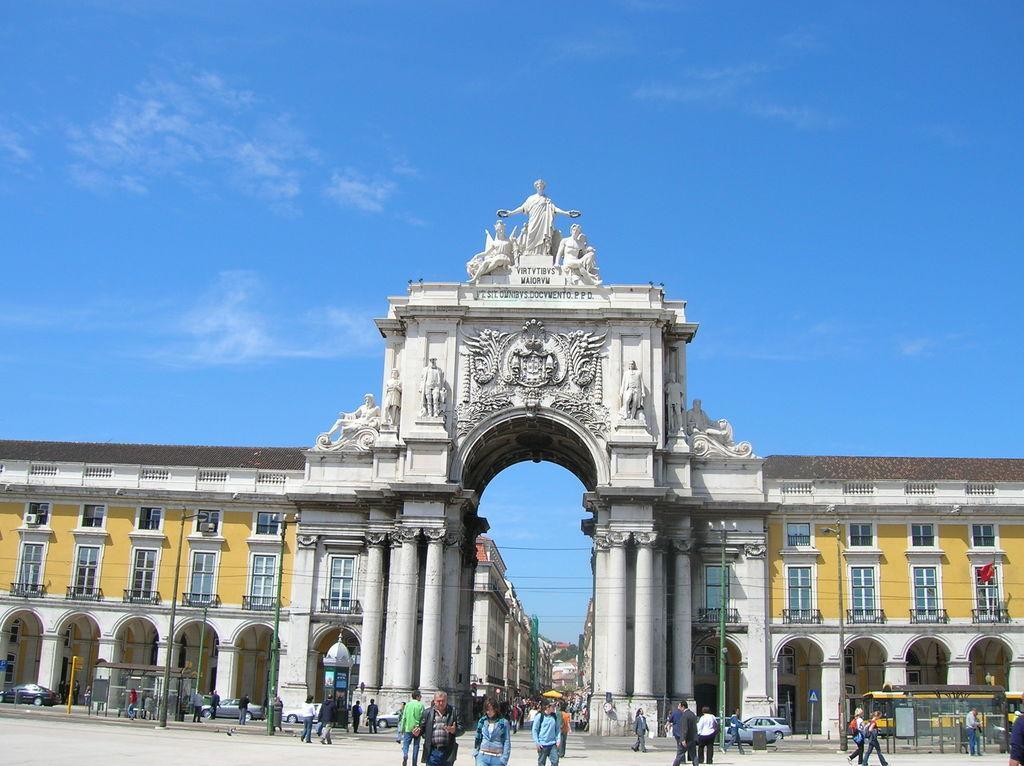Please provide a concise description of this image. At the center of the image there are some buildings, in front of the buildings there are some vehicles and some people are on the road. In the background there is the sky. 